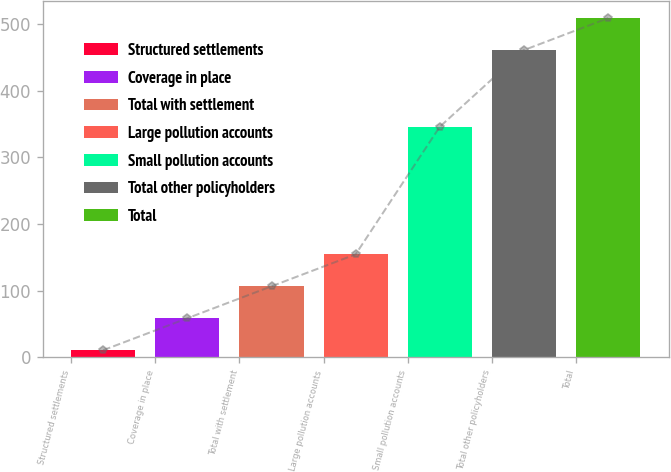Convert chart to OTSL. <chart><loc_0><loc_0><loc_500><loc_500><bar_chart><fcel>Structured settlements<fcel>Coverage in place<fcel>Total with settlement<fcel>Large pollution accounts<fcel>Small pollution accounts<fcel>Total other policyholders<fcel>Total<nl><fcel>11<fcel>58.9<fcel>106.8<fcel>154.7<fcel>346<fcel>461<fcel>508.9<nl></chart> 